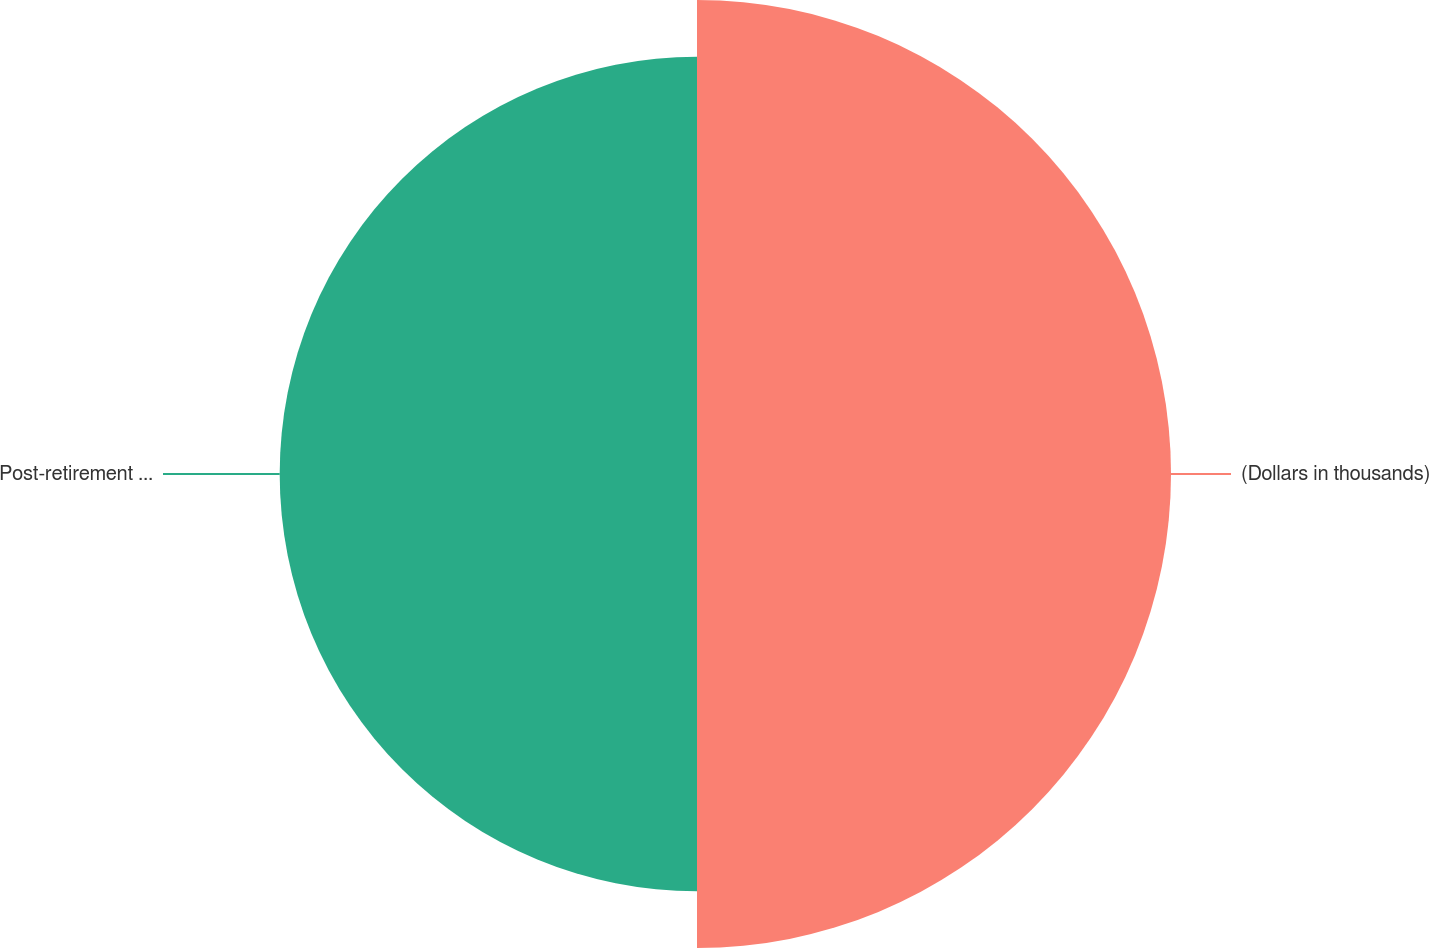Convert chart to OTSL. <chart><loc_0><loc_0><loc_500><loc_500><pie_chart><fcel>(Dollars in thousands)<fcel>Post-retirement benefit<nl><fcel>53.18%<fcel>46.82%<nl></chart> 